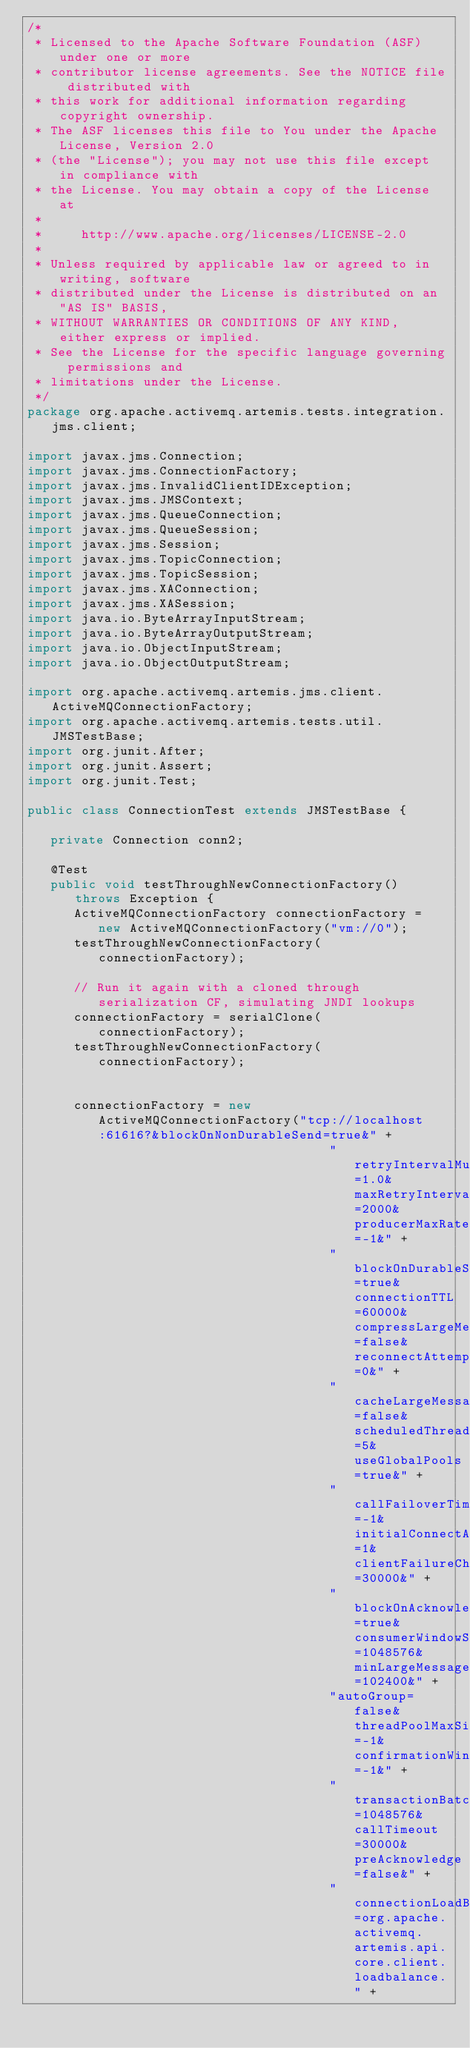<code> <loc_0><loc_0><loc_500><loc_500><_Java_>/*
 * Licensed to the Apache Software Foundation (ASF) under one or more
 * contributor license agreements. See the NOTICE file distributed with
 * this work for additional information regarding copyright ownership.
 * The ASF licenses this file to You under the Apache License, Version 2.0
 * (the "License"); you may not use this file except in compliance with
 * the License. You may obtain a copy of the License at
 *
 *     http://www.apache.org/licenses/LICENSE-2.0
 *
 * Unless required by applicable law or agreed to in writing, software
 * distributed under the License is distributed on an "AS IS" BASIS,
 * WITHOUT WARRANTIES OR CONDITIONS OF ANY KIND, either express or implied.
 * See the License for the specific language governing permissions and
 * limitations under the License.
 */
package org.apache.activemq.artemis.tests.integration.jms.client;

import javax.jms.Connection;
import javax.jms.ConnectionFactory;
import javax.jms.InvalidClientIDException;
import javax.jms.JMSContext;
import javax.jms.QueueConnection;
import javax.jms.QueueSession;
import javax.jms.Session;
import javax.jms.TopicConnection;
import javax.jms.TopicSession;
import javax.jms.XAConnection;
import javax.jms.XASession;
import java.io.ByteArrayInputStream;
import java.io.ByteArrayOutputStream;
import java.io.ObjectInputStream;
import java.io.ObjectOutputStream;

import org.apache.activemq.artemis.jms.client.ActiveMQConnectionFactory;
import org.apache.activemq.artemis.tests.util.JMSTestBase;
import org.junit.After;
import org.junit.Assert;
import org.junit.Test;

public class ConnectionTest extends JMSTestBase {

   private Connection conn2;

   @Test
   public void testThroughNewConnectionFactory() throws Exception {
      ActiveMQConnectionFactory connectionFactory = new ActiveMQConnectionFactory("vm://0");
      testThroughNewConnectionFactory(connectionFactory);

      // Run it again with a cloned through serialization CF, simulating JNDI lookups
      connectionFactory = serialClone(connectionFactory);
      testThroughNewConnectionFactory(connectionFactory);


      connectionFactory = new ActiveMQConnectionFactory("tcp://localhost:61616?&blockOnNonDurableSend=true&" +
                                       "retryIntervalMultiplier=1.0&maxRetryInterval=2000&producerMaxRate=-1&" +
                                       "blockOnDurableSend=true&connectionTTL=60000&compressLargeMessage=false&reconnectAttempts=0&" +
                                       "cacheLargeMessagesClient=false&scheduledThreadPoolMaxSize=5&useGlobalPools=true&" +
                                       "callFailoverTimeout=-1&initialConnectAttempts=1&clientFailureCheckPeriod=30000&" +
                                       "blockOnAcknowledge=true&consumerWindowSize=1048576&minLargeMessageSize=102400&" +
                                       "autoGroup=false&threadPoolMaxSize=-1&confirmationWindowSize=-1&" +
                                       "transactionBatchSize=1048576&callTimeout=30000&preAcknowledge=false&" +
                                       "connectionLoadBalancingPolicyClassName=org.apache.activemq.artemis.api.core.client.loadbalance." +</code> 